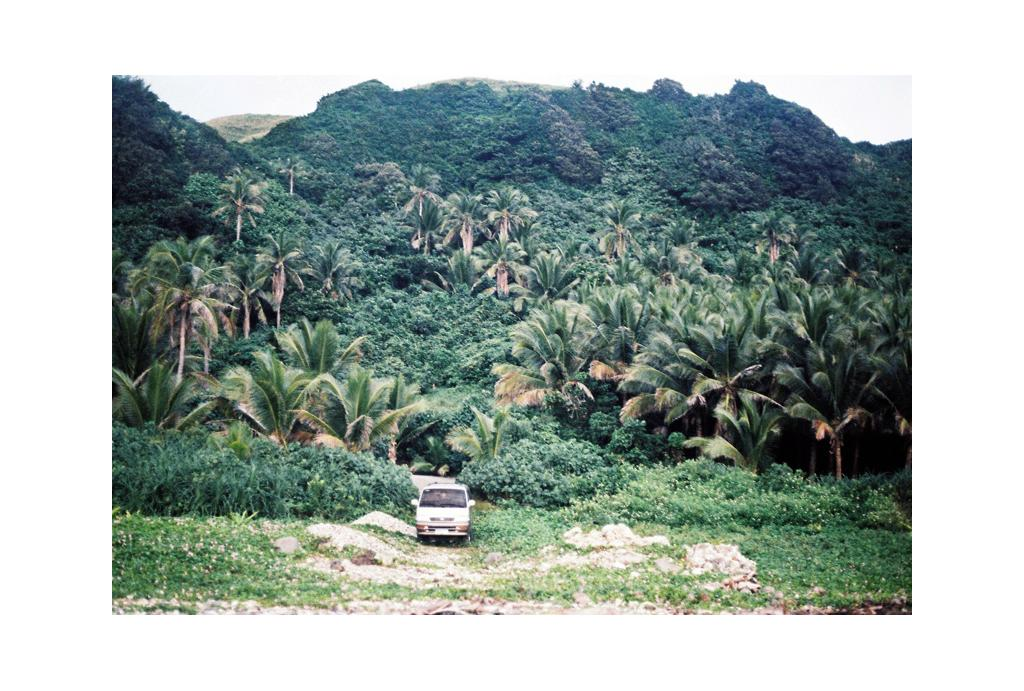What is the main subject in the foreground of the image? There is a van in the foreground of the image. What is the van doing in the image? The van is moving on a path. What can be seen in the background of the image? There are trees, mountains, and the sky visible in the background of the image. What type of leg is visible in the image? There is no leg visible in the image; it features a van moving on a path with trees, mountains, and the sky in the background. 